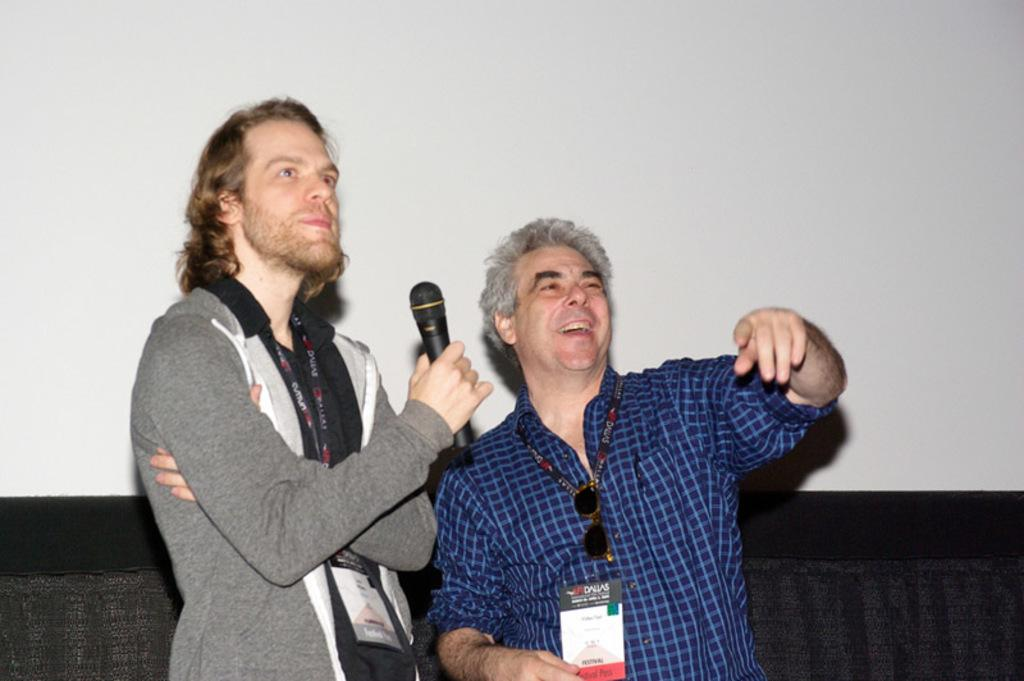How many people are in the image? A: There are two people in the image. What is the facial expression of the people in the image? Both people are smiling in the image. What is one person holding in the image? One person is holding a microphone. What type of badge is the person wearing in the image? There is no badge visible on either person in the image. What emotion does the person feel after giving their speech in the image? The image does not provide information about the person's emotions after giving a speech, as it only shows them smiling while holding a microphone. 